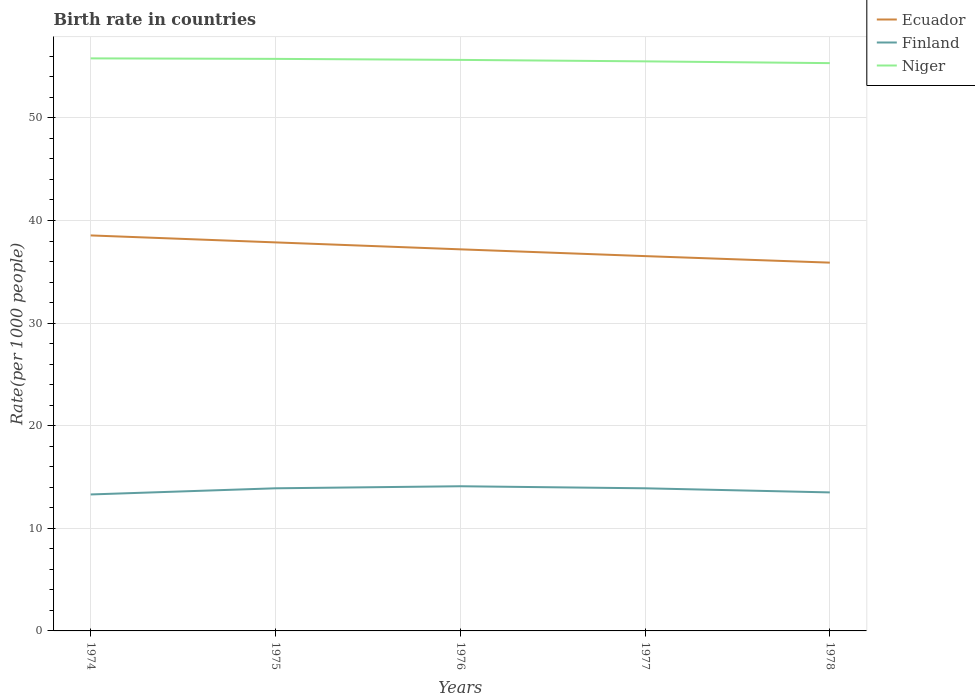Does the line corresponding to Ecuador intersect with the line corresponding to Finland?
Give a very brief answer. No. Is the number of lines equal to the number of legend labels?
Your response must be concise. Yes. In which year was the birth rate in Niger maximum?
Make the answer very short. 1978. What is the total birth rate in Niger in the graph?
Make the answer very short. 0.14. What is the difference between the highest and the second highest birth rate in Ecuador?
Your response must be concise. 2.65. What is the difference between the highest and the lowest birth rate in Ecuador?
Offer a terse response. 2. How many lines are there?
Your response must be concise. 3. How many years are there in the graph?
Offer a very short reply. 5. What is the difference between two consecutive major ticks on the Y-axis?
Offer a very short reply. 10. Are the values on the major ticks of Y-axis written in scientific E-notation?
Offer a terse response. No. Does the graph contain any zero values?
Ensure brevity in your answer.  No. Where does the legend appear in the graph?
Give a very brief answer. Top right. What is the title of the graph?
Make the answer very short. Birth rate in countries. What is the label or title of the Y-axis?
Make the answer very short. Rate(per 1000 people). What is the Rate(per 1000 people) of Ecuador in 1974?
Your answer should be very brief. 38.54. What is the Rate(per 1000 people) in Finland in 1974?
Provide a succinct answer. 13.3. What is the Rate(per 1000 people) in Niger in 1974?
Your response must be concise. 55.8. What is the Rate(per 1000 people) in Ecuador in 1975?
Offer a very short reply. 37.87. What is the Rate(per 1000 people) of Finland in 1975?
Ensure brevity in your answer.  13.9. What is the Rate(per 1000 people) in Niger in 1975?
Offer a terse response. 55.75. What is the Rate(per 1000 people) of Ecuador in 1976?
Provide a short and direct response. 37.19. What is the Rate(per 1000 people) of Finland in 1976?
Offer a terse response. 14.1. What is the Rate(per 1000 people) in Niger in 1976?
Offer a very short reply. 55.65. What is the Rate(per 1000 people) of Ecuador in 1977?
Ensure brevity in your answer.  36.53. What is the Rate(per 1000 people) in Niger in 1977?
Make the answer very short. 55.51. What is the Rate(per 1000 people) in Ecuador in 1978?
Provide a short and direct response. 35.89. What is the Rate(per 1000 people) in Finland in 1978?
Your answer should be very brief. 13.5. What is the Rate(per 1000 people) of Niger in 1978?
Keep it short and to the point. 55.34. Across all years, what is the maximum Rate(per 1000 people) of Ecuador?
Offer a terse response. 38.54. Across all years, what is the maximum Rate(per 1000 people) in Niger?
Offer a very short reply. 55.8. Across all years, what is the minimum Rate(per 1000 people) of Ecuador?
Keep it short and to the point. 35.89. Across all years, what is the minimum Rate(per 1000 people) of Finland?
Give a very brief answer. 13.3. Across all years, what is the minimum Rate(per 1000 people) of Niger?
Give a very brief answer. 55.34. What is the total Rate(per 1000 people) of Ecuador in the graph?
Make the answer very short. 186.02. What is the total Rate(per 1000 people) of Finland in the graph?
Offer a terse response. 68.7. What is the total Rate(per 1000 people) of Niger in the graph?
Keep it short and to the point. 278.05. What is the difference between the Rate(per 1000 people) of Ecuador in 1974 and that in 1975?
Keep it short and to the point. 0.68. What is the difference between the Rate(per 1000 people) of Niger in 1974 and that in 1975?
Your answer should be very brief. 0.05. What is the difference between the Rate(per 1000 people) in Ecuador in 1974 and that in 1976?
Provide a succinct answer. 1.35. What is the difference between the Rate(per 1000 people) in Niger in 1974 and that in 1976?
Offer a very short reply. 0.15. What is the difference between the Rate(per 1000 people) of Ecuador in 1974 and that in 1977?
Give a very brief answer. 2.02. What is the difference between the Rate(per 1000 people) of Finland in 1974 and that in 1977?
Your response must be concise. -0.6. What is the difference between the Rate(per 1000 people) of Niger in 1974 and that in 1977?
Provide a succinct answer. 0.29. What is the difference between the Rate(per 1000 people) of Ecuador in 1974 and that in 1978?
Provide a succinct answer. 2.65. What is the difference between the Rate(per 1000 people) of Niger in 1974 and that in 1978?
Keep it short and to the point. 0.46. What is the difference between the Rate(per 1000 people) of Ecuador in 1975 and that in 1976?
Give a very brief answer. 0.68. What is the difference between the Rate(per 1000 people) of Finland in 1975 and that in 1976?
Offer a very short reply. -0.2. What is the difference between the Rate(per 1000 people) of Niger in 1975 and that in 1976?
Your response must be concise. 0.1. What is the difference between the Rate(per 1000 people) of Ecuador in 1975 and that in 1977?
Your response must be concise. 1.34. What is the difference between the Rate(per 1000 people) of Niger in 1975 and that in 1977?
Provide a short and direct response. 0.24. What is the difference between the Rate(per 1000 people) in Ecuador in 1975 and that in 1978?
Give a very brief answer. 1.97. What is the difference between the Rate(per 1000 people) of Niger in 1975 and that in 1978?
Make the answer very short. 0.41. What is the difference between the Rate(per 1000 people) of Ecuador in 1976 and that in 1977?
Ensure brevity in your answer.  0.66. What is the difference between the Rate(per 1000 people) of Finland in 1976 and that in 1977?
Your answer should be compact. 0.2. What is the difference between the Rate(per 1000 people) of Niger in 1976 and that in 1977?
Your answer should be compact. 0.14. What is the difference between the Rate(per 1000 people) in Ecuador in 1976 and that in 1978?
Make the answer very short. 1.3. What is the difference between the Rate(per 1000 people) in Niger in 1976 and that in 1978?
Ensure brevity in your answer.  0.31. What is the difference between the Rate(per 1000 people) of Ecuador in 1977 and that in 1978?
Give a very brief answer. 0.64. What is the difference between the Rate(per 1000 people) of Finland in 1977 and that in 1978?
Keep it short and to the point. 0.4. What is the difference between the Rate(per 1000 people) of Niger in 1977 and that in 1978?
Provide a short and direct response. 0.17. What is the difference between the Rate(per 1000 people) in Ecuador in 1974 and the Rate(per 1000 people) in Finland in 1975?
Provide a succinct answer. 24.64. What is the difference between the Rate(per 1000 people) of Ecuador in 1974 and the Rate(per 1000 people) of Niger in 1975?
Your answer should be very brief. -17.21. What is the difference between the Rate(per 1000 people) of Finland in 1974 and the Rate(per 1000 people) of Niger in 1975?
Provide a succinct answer. -42.45. What is the difference between the Rate(per 1000 people) in Ecuador in 1974 and the Rate(per 1000 people) in Finland in 1976?
Offer a very short reply. 24.44. What is the difference between the Rate(per 1000 people) in Ecuador in 1974 and the Rate(per 1000 people) in Niger in 1976?
Provide a short and direct response. -17.11. What is the difference between the Rate(per 1000 people) of Finland in 1974 and the Rate(per 1000 people) of Niger in 1976?
Provide a short and direct response. -42.35. What is the difference between the Rate(per 1000 people) of Ecuador in 1974 and the Rate(per 1000 people) of Finland in 1977?
Make the answer very short. 24.64. What is the difference between the Rate(per 1000 people) in Ecuador in 1974 and the Rate(per 1000 people) in Niger in 1977?
Offer a very short reply. -16.96. What is the difference between the Rate(per 1000 people) of Finland in 1974 and the Rate(per 1000 people) of Niger in 1977?
Ensure brevity in your answer.  -42.21. What is the difference between the Rate(per 1000 people) in Ecuador in 1974 and the Rate(per 1000 people) in Finland in 1978?
Your response must be concise. 25.04. What is the difference between the Rate(per 1000 people) of Ecuador in 1974 and the Rate(per 1000 people) of Niger in 1978?
Keep it short and to the point. -16.79. What is the difference between the Rate(per 1000 people) in Finland in 1974 and the Rate(per 1000 people) in Niger in 1978?
Your answer should be compact. -42.04. What is the difference between the Rate(per 1000 people) in Ecuador in 1975 and the Rate(per 1000 people) in Finland in 1976?
Ensure brevity in your answer.  23.77. What is the difference between the Rate(per 1000 people) in Ecuador in 1975 and the Rate(per 1000 people) in Niger in 1976?
Keep it short and to the point. -17.79. What is the difference between the Rate(per 1000 people) of Finland in 1975 and the Rate(per 1000 people) of Niger in 1976?
Make the answer very short. -41.75. What is the difference between the Rate(per 1000 people) in Ecuador in 1975 and the Rate(per 1000 people) in Finland in 1977?
Your answer should be very brief. 23.96. What is the difference between the Rate(per 1000 people) of Ecuador in 1975 and the Rate(per 1000 people) of Niger in 1977?
Your response must be concise. -17.64. What is the difference between the Rate(per 1000 people) in Finland in 1975 and the Rate(per 1000 people) in Niger in 1977?
Your answer should be compact. -41.61. What is the difference between the Rate(per 1000 people) of Ecuador in 1975 and the Rate(per 1000 people) of Finland in 1978?
Give a very brief answer. 24.36. What is the difference between the Rate(per 1000 people) of Ecuador in 1975 and the Rate(per 1000 people) of Niger in 1978?
Ensure brevity in your answer.  -17.47. What is the difference between the Rate(per 1000 people) of Finland in 1975 and the Rate(per 1000 people) of Niger in 1978?
Give a very brief answer. -41.44. What is the difference between the Rate(per 1000 people) in Ecuador in 1976 and the Rate(per 1000 people) in Finland in 1977?
Offer a very short reply. 23.29. What is the difference between the Rate(per 1000 people) of Ecuador in 1976 and the Rate(per 1000 people) of Niger in 1977?
Your answer should be very brief. -18.32. What is the difference between the Rate(per 1000 people) in Finland in 1976 and the Rate(per 1000 people) in Niger in 1977?
Ensure brevity in your answer.  -41.41. What is the difference between the Rate(per 1000 people) of Ecuador in 1976 and the Rate(per 1000 people) of Finland in 1978?
Your answer should be compact. 23.69. What is the difference between the Rate(per 1000 people) in Ecuador in 1976 and the Rate(per 1000 people) in Niger in 1978?
Offer a very short reply. -18.15. What is the difference between the Rate(per 1000 people) in Finland in 1976 and the Rate(per 1000 people) in Niger in 1978?
Make the answer very short. -41.24. What is the difference between the Rate(per 1000 people) in Ecuador in 1977 and the Rate(per 1000 people) in Finland in 1978?
Offer a terse response. 23.03. What is the difference between the Rate(per 1000 people) in Ecuador in 1977 and the Rate(per 1000 people) in Niger in 1978?
Provide a short and direct response. -18.81. What is the difference between the Rate(per 1000 people) of Finland in 1977 and the Rate(per 1000 people) of Niger in 1978?
Provide a succinct answer. -41.44. What is the average Rate(per 1000 people) in Ecuador per year?
Your answer should be very brief. 37.2. What is the average Rate(per 1000 people) of Finland per year?
Your response must be concise. 13.74. What is the average Rate(per 1000 people) of Niger per year?
Offer a very short reply. 55.61. In the year 1974, what is the difference between the Rate(per 1000 people) in Ecuador and Rate(per 1000 people) in Finland?
Your answer should be very brief. 25.24. In the year 1974, what is the difference between the Rate(per 1000 people) of Ecuador and Rate(per 1000 people) of Niger?
Offer a very short reply. -17.25. In the year 1974, what is the difference between the Rate(per 1000 people) in Finland and Rate(per 1000 people) in Niger?
Ensure brevity in your answer.  -42.5. In the year 1975, what is the difference between the Rate(per 1000 people) in Ecuador and Rate(per 1000 people) in Finland?
Give a very brief answer. 23.96. In the year 1975, what is the difference between the Rate(per 1000 people) in Ecuador and Rate(per 1000 people) in Niger?
Provide a short and direct response. -17.89. In the year 1975, what is the difference between the Rate(per 1000 people) in Finland and Rate(per 1000 people) in Niger?
Provide a succinct answer. -41.85. In the year 1976, what is the difference between the Rate(per 1000 people) in Ecuador and Rate(per 1000 people) in Finland?
Give a very brief answer. 23.09. In the year 1976, what is the difference between the Rate(per 1000 people) in Ecuador and Rate(per 1000 people) in Niger?
Ensure brevity in your answer.  -18.46. In the year 1976, what is the difference between the Rate(per 1000 people) in Finland and Rate(per 1000 people) in Niger?
Your response must be concise. -41.55. In the year 1977, what is the difference between the Rate(per 1000 people) of Ecuador and Rate(per 1000 people) of Finland?
Your response must be concise. 22.63. In the year 1977, what is the difference between the Rate(per 1000 people) of Ecuador and Rate(per 1000 people) of Niger?
Offer a very short reply. -18.98. In the year 1977, what is the difference between the Rate(per 1000 people) in Finland and Rate(per 1000 people) in Niger?
Your answer should be compact. -41.61. In the year 1978, what is the difference between the Rate(per 1000 people) in Ecuador and Rate(per 1000 people) in Finland?
Offer a terse response. 22.39. In the year 1978, what is the difference between the Rate(per 1000 people) in Ecuador and Rate(per 1000 people) in Niger?
Give a very brief answer. -19.45. In the year 1978, what is the difference between the Rate(per 1000 people) in Finland and Rate(per 1000 people) in Niger?
Offer a terse response. -41.84. What is the ratio of the Rate(per 1000 people) in Ecuador in 1974 to that in 1975?
Offer a terse response. 1.02. What is the ratio of the Rate(per 1000 people) in Finland in 1974 to that in 1975?
Provide a short and direct response. 0.96. What is the ratio of the Rate(per 1000 people) in Niger in 1974 to that in 1975?
Offer a terse response. 1. What is the ratio of the Rate(per 1000 people) in Ecuador in 1974 to that in 1976?
Provide a short and direct response. 1.04. What is the ratio of the Rate(per 1000 people) in Finland in 1974 to that in 1976?
Offer a very short reply. 0.94. What is the ratio of the Rate(per 1000 people) of Ecuador in 1974 to that in 1977?
Provide a short and direct response. 1.06. What is the ratio of the Rate(per 1000 people) in Finland in 1974 to that in 1977?
Keep it short and to the point. 0.96. What is the ratio of the Rate(per 1000 people) in Niger in 1974 to that in 1977?
Keep it short and to the point. 1.01. What is the ratio of the Rate(per 1000 people) in Ecuador in 1974 to that in 1978?
Your answer should be very brief. 1.07. What is the ratio of the Rate(per 1000 people) in Finland in 1974 to that in 1978?
Give a very brief answer. 0.99. What is the ratio of the Rate(per 1000 people) of Niger in 1974 to that in 1978?
Make the answer very short. 1.01. What is the ratio of the Rate(per 1000 people) in Ecuador in 1975 to that in 1976?
Provide a short and direct response. 1.02. What is the ratio of the Rate(per 1000 people) of Finland in 1975 to that in 1976?
Provide a short and direct response. 0.99. What is the ratio of the Rate(per 1000 people) in Ecuador in 1975 to that in 1977?
Provide a succinct answer. 1.04. What is the ratio of the Rate(per 1000 people) of Ecuador in 1975 to that in 1978?
Give a very brief answer. 1.05. What is the ratio of the Rate(per 1000 people) in Finland in 1975 to that in 1978?
Keep it short and to the point. 1.03. What is the ratio of the Rate(per 1000 people) in Niger in 1975 to that in 1978?
Make the answer very short. 1.01. What is the ratio of the Rate(per 1000 people) of Ecuador in 1976 to that in 1977?
Offer a very short reply. 1.02. What is the ratio of the Rate(per 1000 people) of Finland in 1976 to that in 1977?
Offer a very short reply. 1.01. What is the ratio of the Rate(per 1000 people) of Ecuador in 1976 to that in 1978?
Keep it short and to the point. 1.04. What is the ratio of the Rate(per 1000 people) in Finland in 1976 to that in 1978?
Offer a very short reply. 1.04. What is the ratio of the Rate(per 1000 people) of Ecuador in 1977 to that in 1978?
Your response must be concise. 1.02. What is the ratio of the Rate(per 1000 people) of Finland in 1977 to that in 1978?
Provide a short and direct response. 1.03. What is the ratio of the Rate(per 1000 people) in Niger in 1977 to that in 1978?
Ensure brevity in your answer.  1. What is the difference between the highest and the second highest Rate(per 1000 people) in Ecuador?
Provide a succinct answer. 0.68. What is the difference between the highest and the second highest Rate(per 1000 people) of Finland?
Provide a succinct answer. 0.2. What is the difference between the highest and the second highest Rate(per 1000 people) in Niger?
Provide a succinct answer. 0.05. What is the difference between the highest and the lowest Rate(per 1000 people) in Ecuador?
Your response must be concise. 2.65. What is the difference between the highest and the lowest Rate(per 1000 people) in Niger?
Provide a succinct answer. 0.46. 